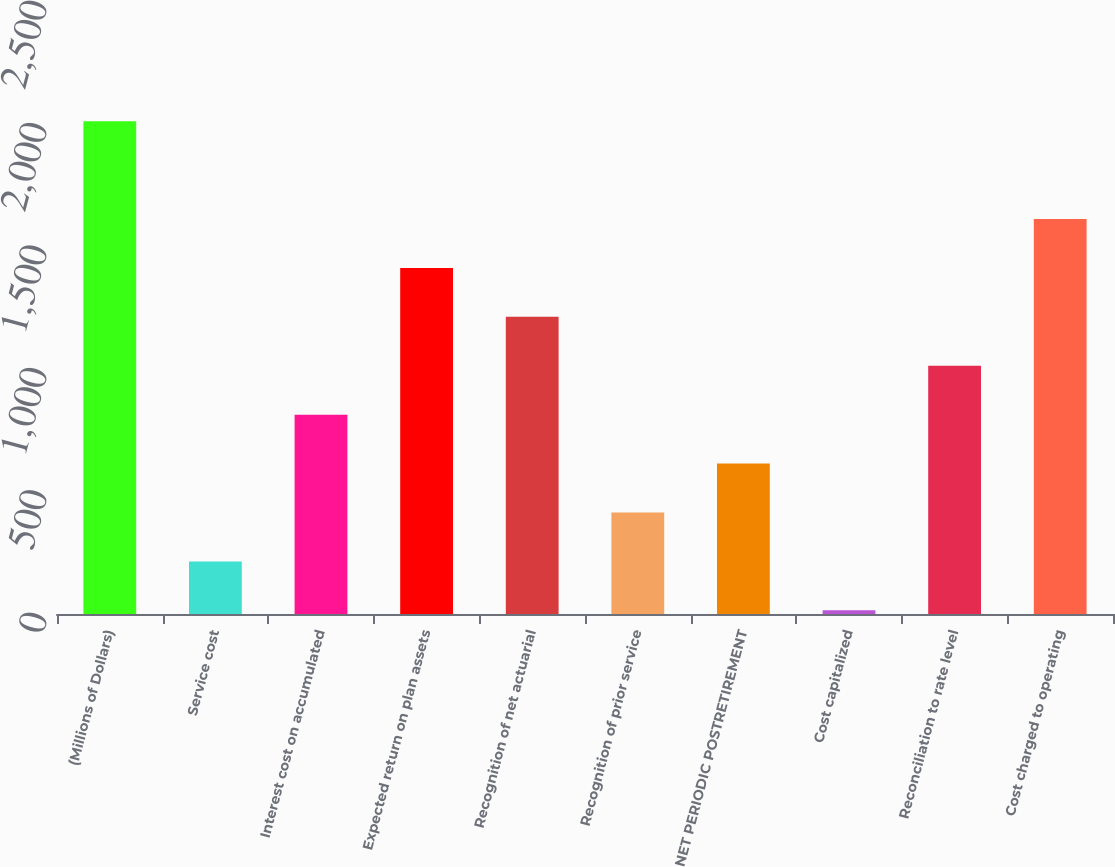Convert chart. <chart><loc_0><loc_0><loc_500><loc_500><bar_chart><fcel>(Millions of Dollars)<fcel>Service cost<fcel>Interest cost on accumulated<fcel>Expected return on plan assets<fcel>Recognition of net actuarial<fcel>Recognition of prior service<fcel>NET PERIODIC POSTRETIREMENT<fcel>Cost capitalized<fcel>Reconciliation to rate level<fcel>Cost charged to operating<nl><fcel>2013<fcel>214.8<fcel>814.2<fcel>1413.6<fcel>1213.8<fcel>414.6<fcel>614.4<fcel>15<fcel>1014<fcel>1613.4<nl></chart> 